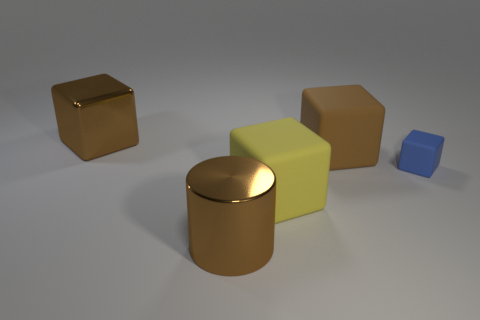What shape is the large brown shiny thing to the right of the big brown thing on the left side of the big cylinder that is on the left side of the tiny matte thing? The large brown shiny thing to the right of the big brown object, which is a cube, on the left side of the large cylinder, is also a cylinder. It has a reflective surface that distinguishes it from the other matte-finished objects in the image. 